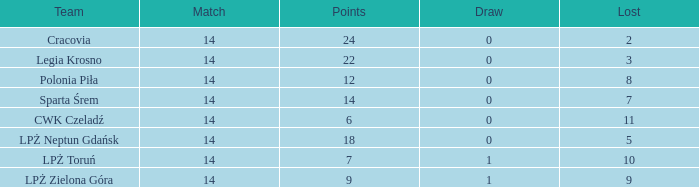What is the sum for the match with a draw less than 0? None. 